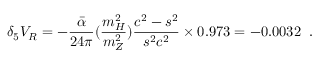<formula> <loc_0><loc_0><loc_500><loc_500>\delta _ { 5 } V _ { R } = - \frac { \bar { \alpha } } { 2 4 \pi } ( \frac { m _ { H } ^ { 2 } } { m _ { Z } ^ { 2 } } ) \frac { c ^ { 2 } - s ^ { 2 } } { s ^ { 2 } c ^ { 2 } } \times 0 . 9 7 3 = - 0 . 0 0 3 2 \, .</formula> 